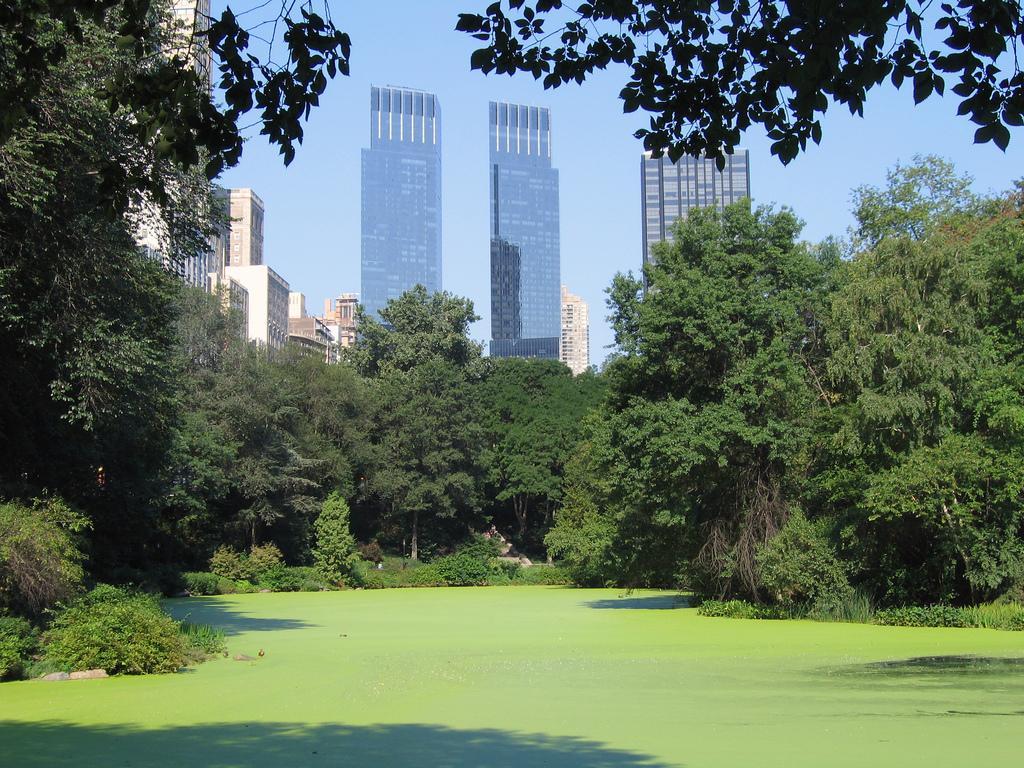How would you summarize this image in a sentence or two? Here we can see water and the outermost layer of it is in greenish color. In the background there are trees,buildings,windows and sky. 